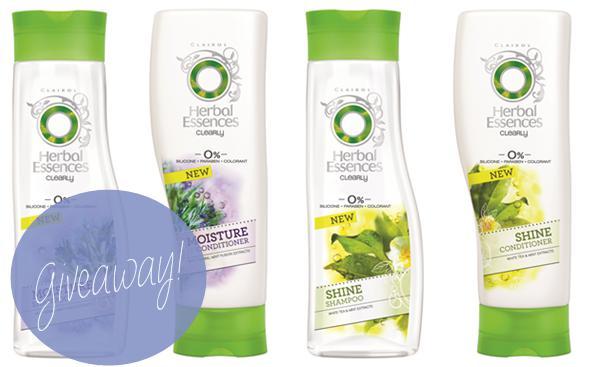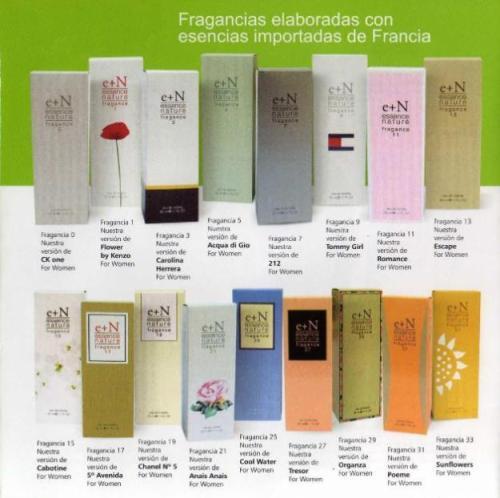The first image is the image on the left, the second image is the image on the right. Assess this claim about the two images: "The box for the product in the image on the left shows a woman's face.". Correct or not? Answer yes or no. No. The first image is the image on the left, the second image is the image on the right. Examine the images to the left and right. Is the description "At least one image shows a spray product standing next to its box." accurate? Answer yes or no. No. 